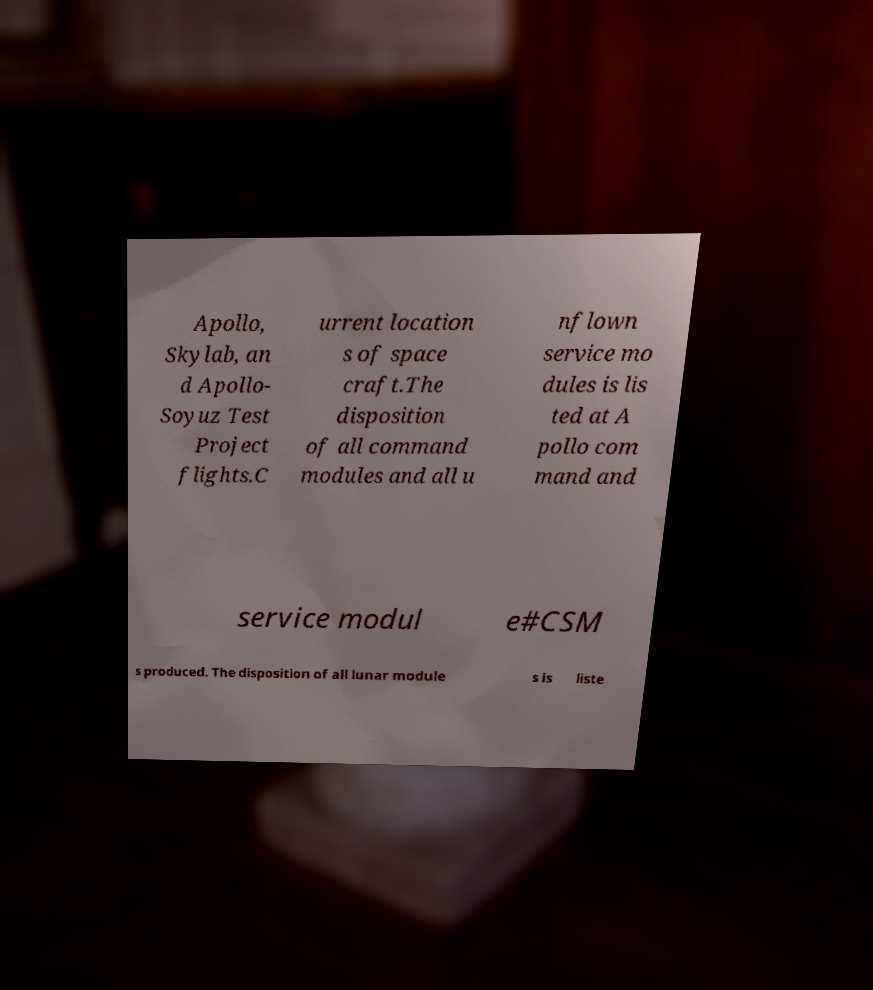Can you accurately transcribe the text from the provided image for me? Apollo, Skylab, an d Apollo- Soyuz Test Project flights.C urrent location s of space craft.The disposition of all command modules and all u nflown service mo dules is lis ted at A pollo com mand and service modul e#CSM s produced. The disposition of all lunar module s is liste 